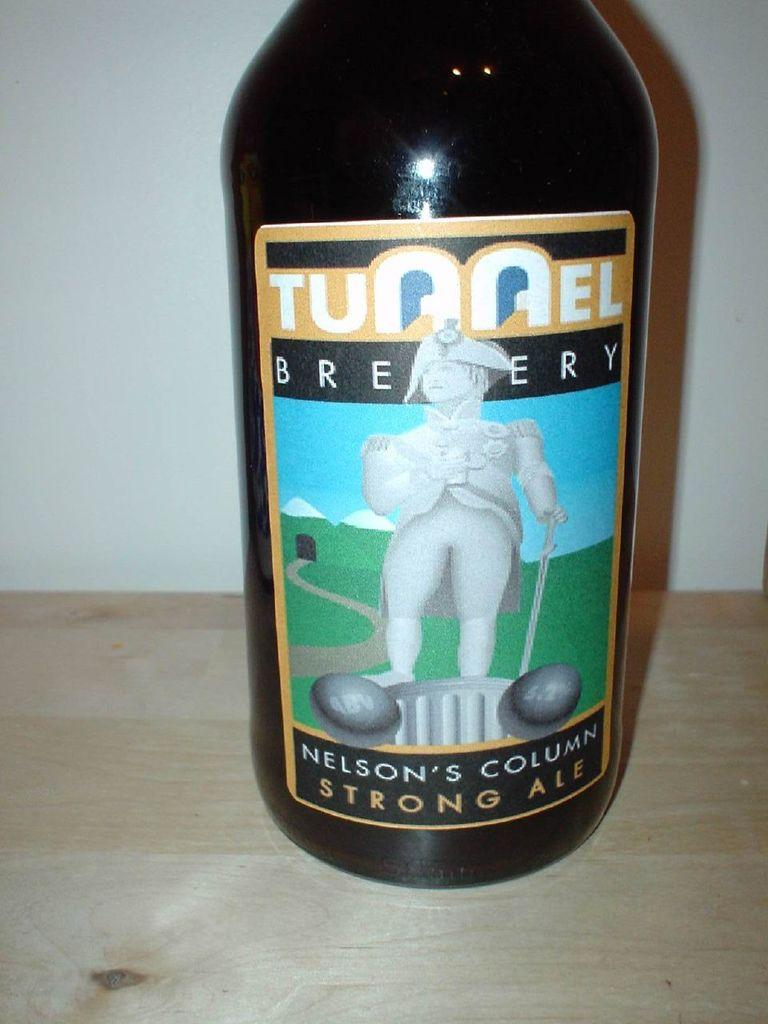<image>
Relay a brief, clear account of the picture shown. A bottle of Tunnel Brewery strong ale with the picture of a military man on it. 